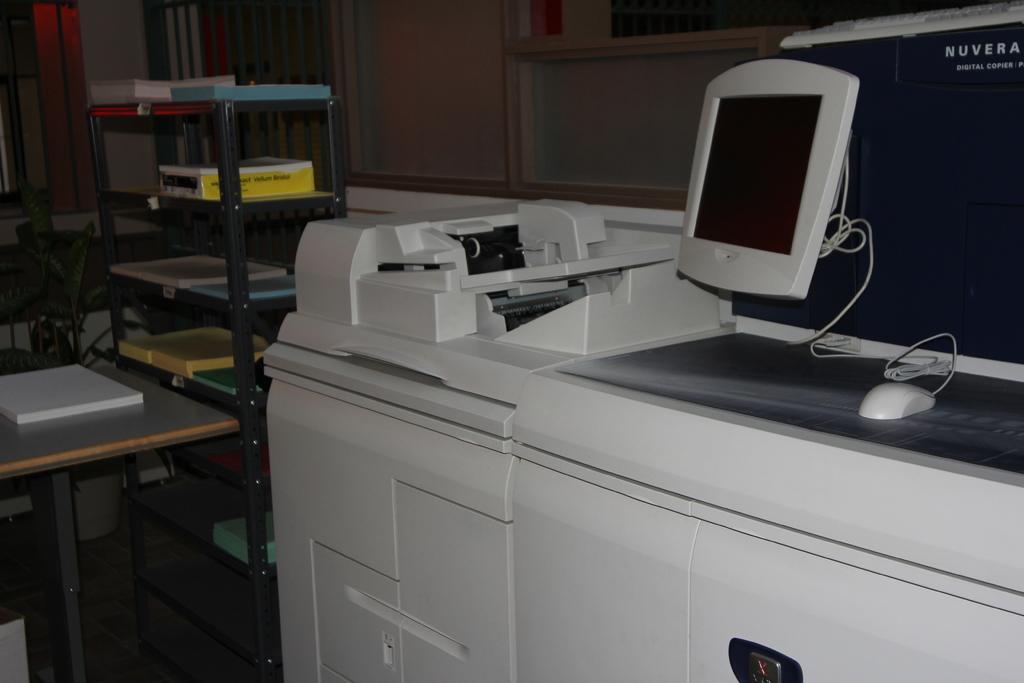What is the brand on the monitor?
Your answer should be very brief. Nuvera. 